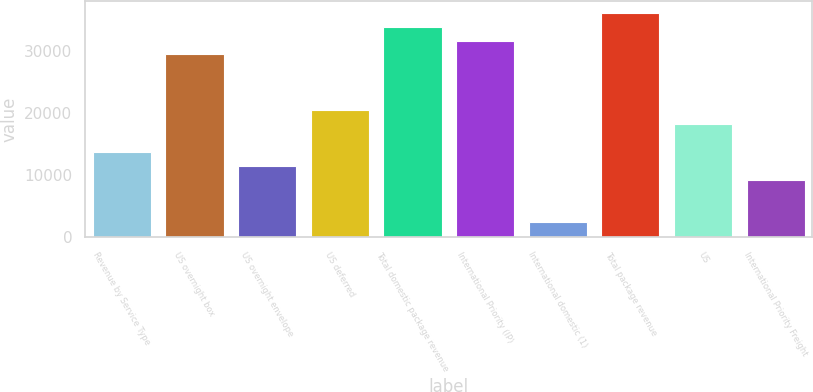<chart> <loc_0><loc_0><loc_500><loc_500><bar_chart><fcel>Revenue by Service Type<fcel>US overnight box<fcel>US overnight envelope<fcel>US deferred<fcel>Total domestic package revenue<fcel>International Priority (IP)<fcel>International domestic (1)<fcel>Total package revenue<fcel>US<fcel>International Priority Freight<nl><fcel>13701.4<fcel>29415.7<fcel>11456.5<fcel>20436.1<fcel>33905.5<fcel>31660.6<fcel>2476.9<fcel>36150.4<fcel>18191.2<fcel>9211.6<nl></chart> 